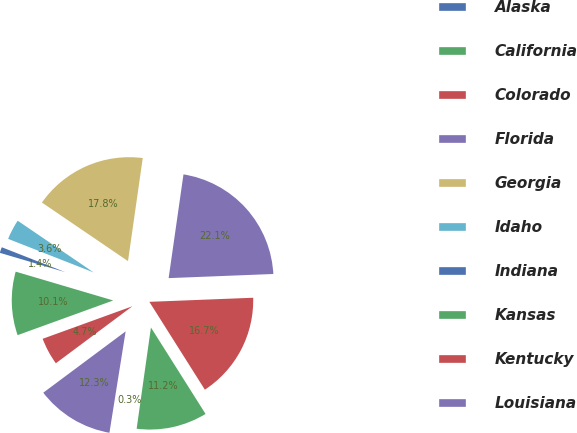Convert chart. <chart><loc_0><loc_0><loc_500><loc_500><pie_chart><fcel>Alaska<fcel>California<fcel>Colorado<fcel>Florida<fcel>Georgia<fcel>Idaho<fcel>Indiana<fcel>Kansas<fcel>Kentucky<fcel>Louisiana<nl><fcel>0.29%<fcel>11.2%<fcel>16.66%<fcel>22.11%<fcel>17.75%<fcel>3.56%<fcel>1.38%<fcel>10.11%<fcel>4.65%<fcel>12.29%<nl></chart> 